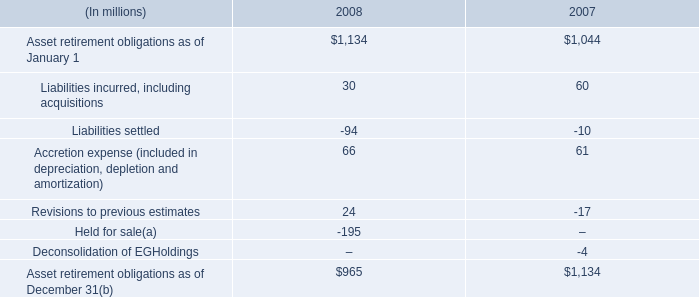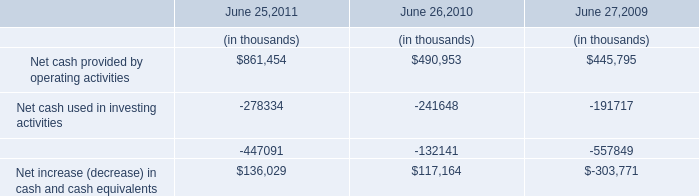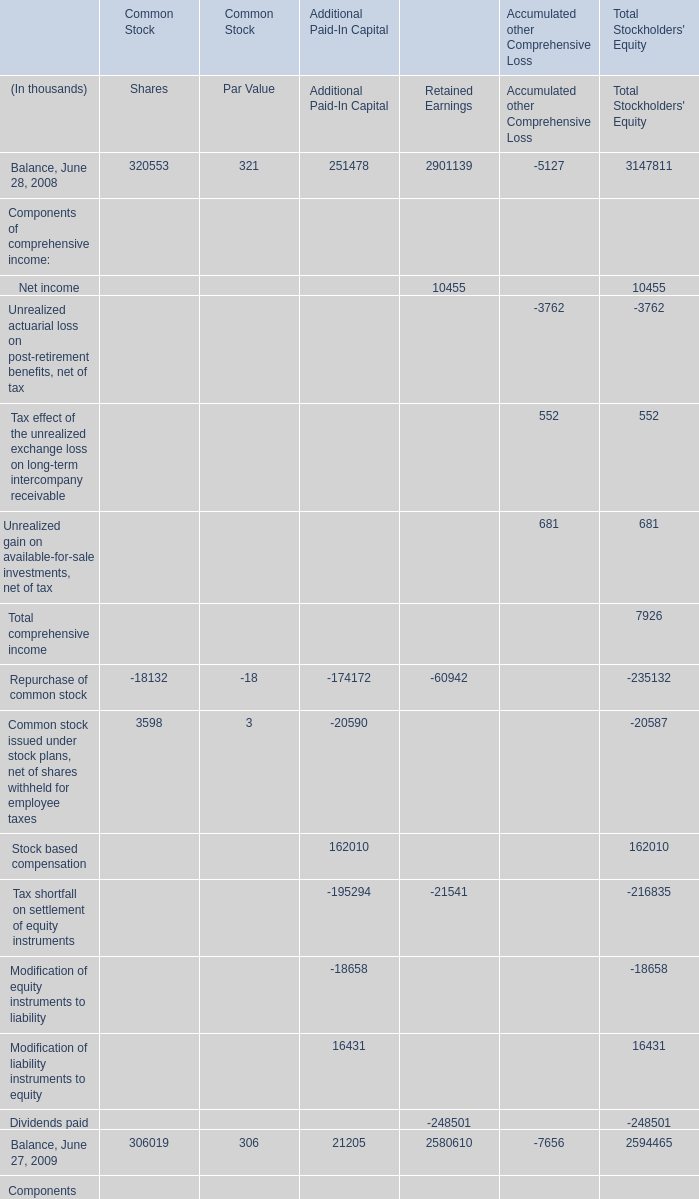by how much did asset retirement obligations decrease from 2007 to 2008? 
Computations: ((965 - 1134) / 1134)
Answer: -0.14903. 